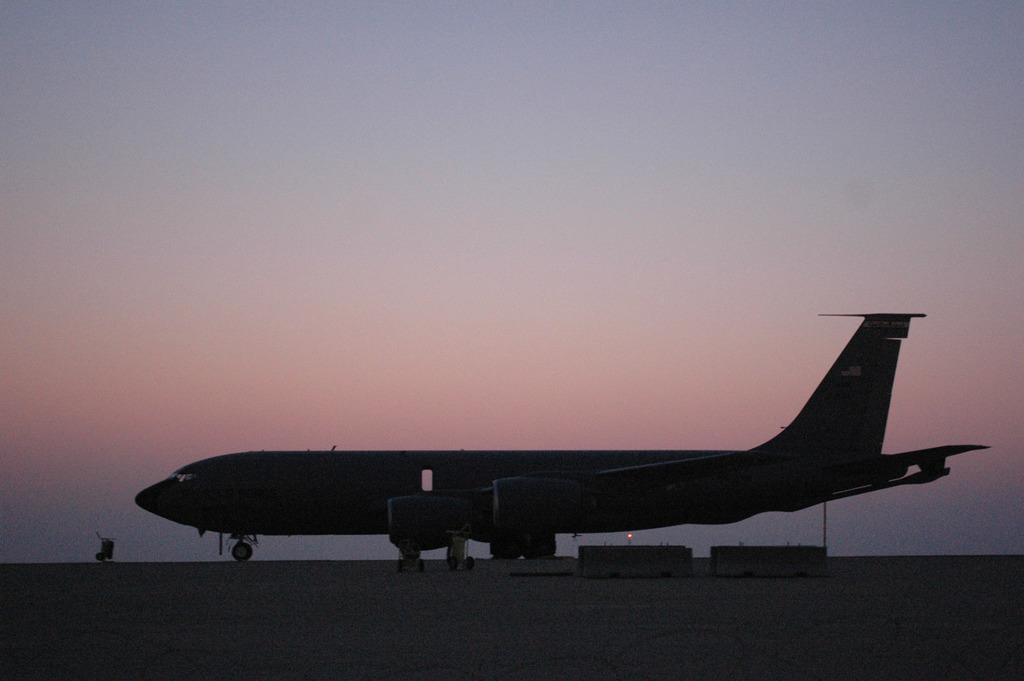What is the main subject of the image? The main subject of the image is an airplane. Where is the airplane located in the image? The airplane is on the ground in the image. What can be seen in the background of the image? There is a dark sky visible in the background of the image. What type of development can be seen taking place near the airplane in the image? There is no development or construction activity visible in the image; it only features an airplane on the ground with a dark sky in the background. 